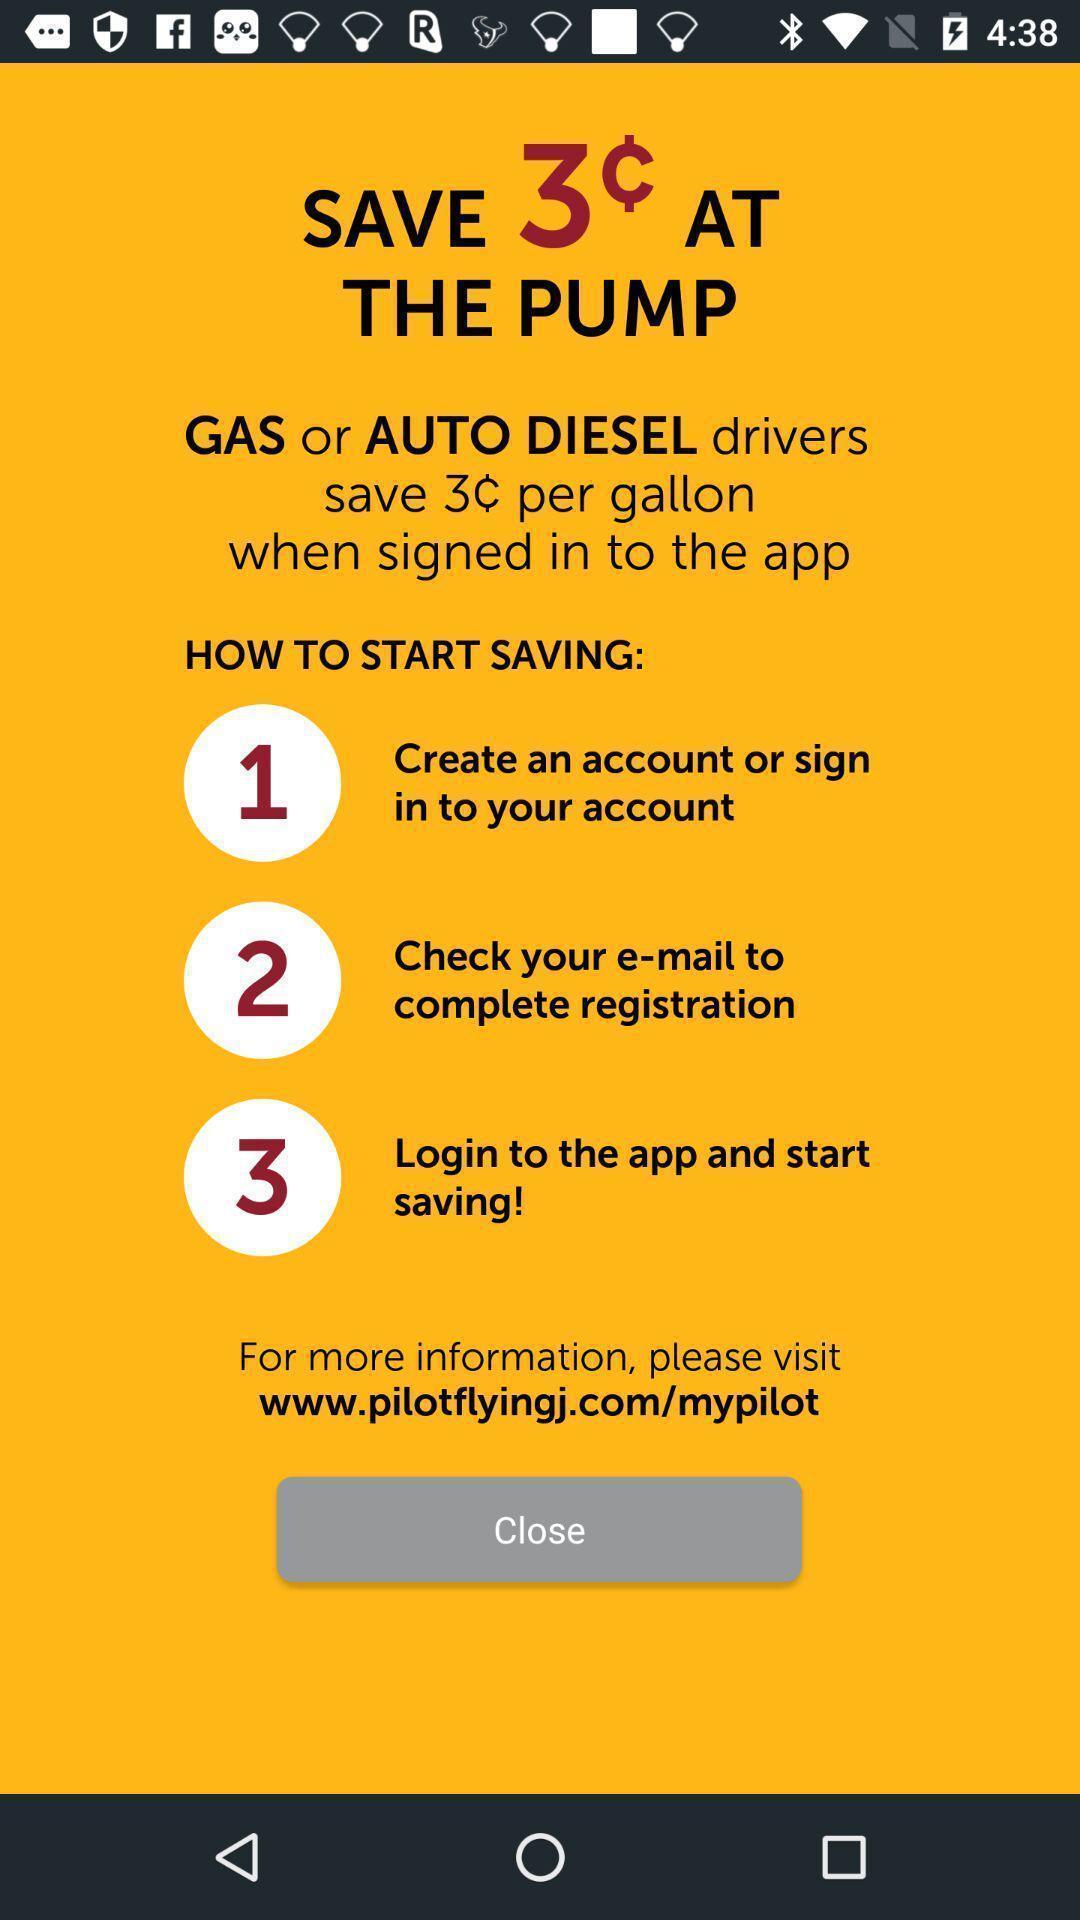Describe the key features of this screenshot. Screen shows about trip planner. 